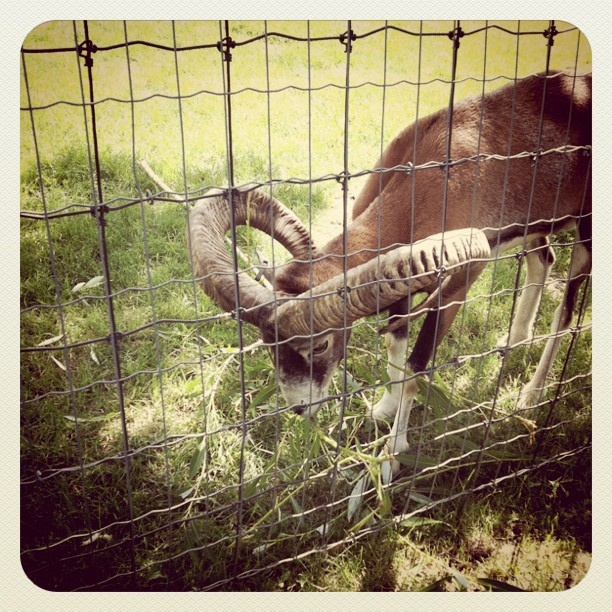Describe the objects in this image and their specific colors. I can see a sheep in ivory, gray, maroon, brown, and tan tones in this image. 